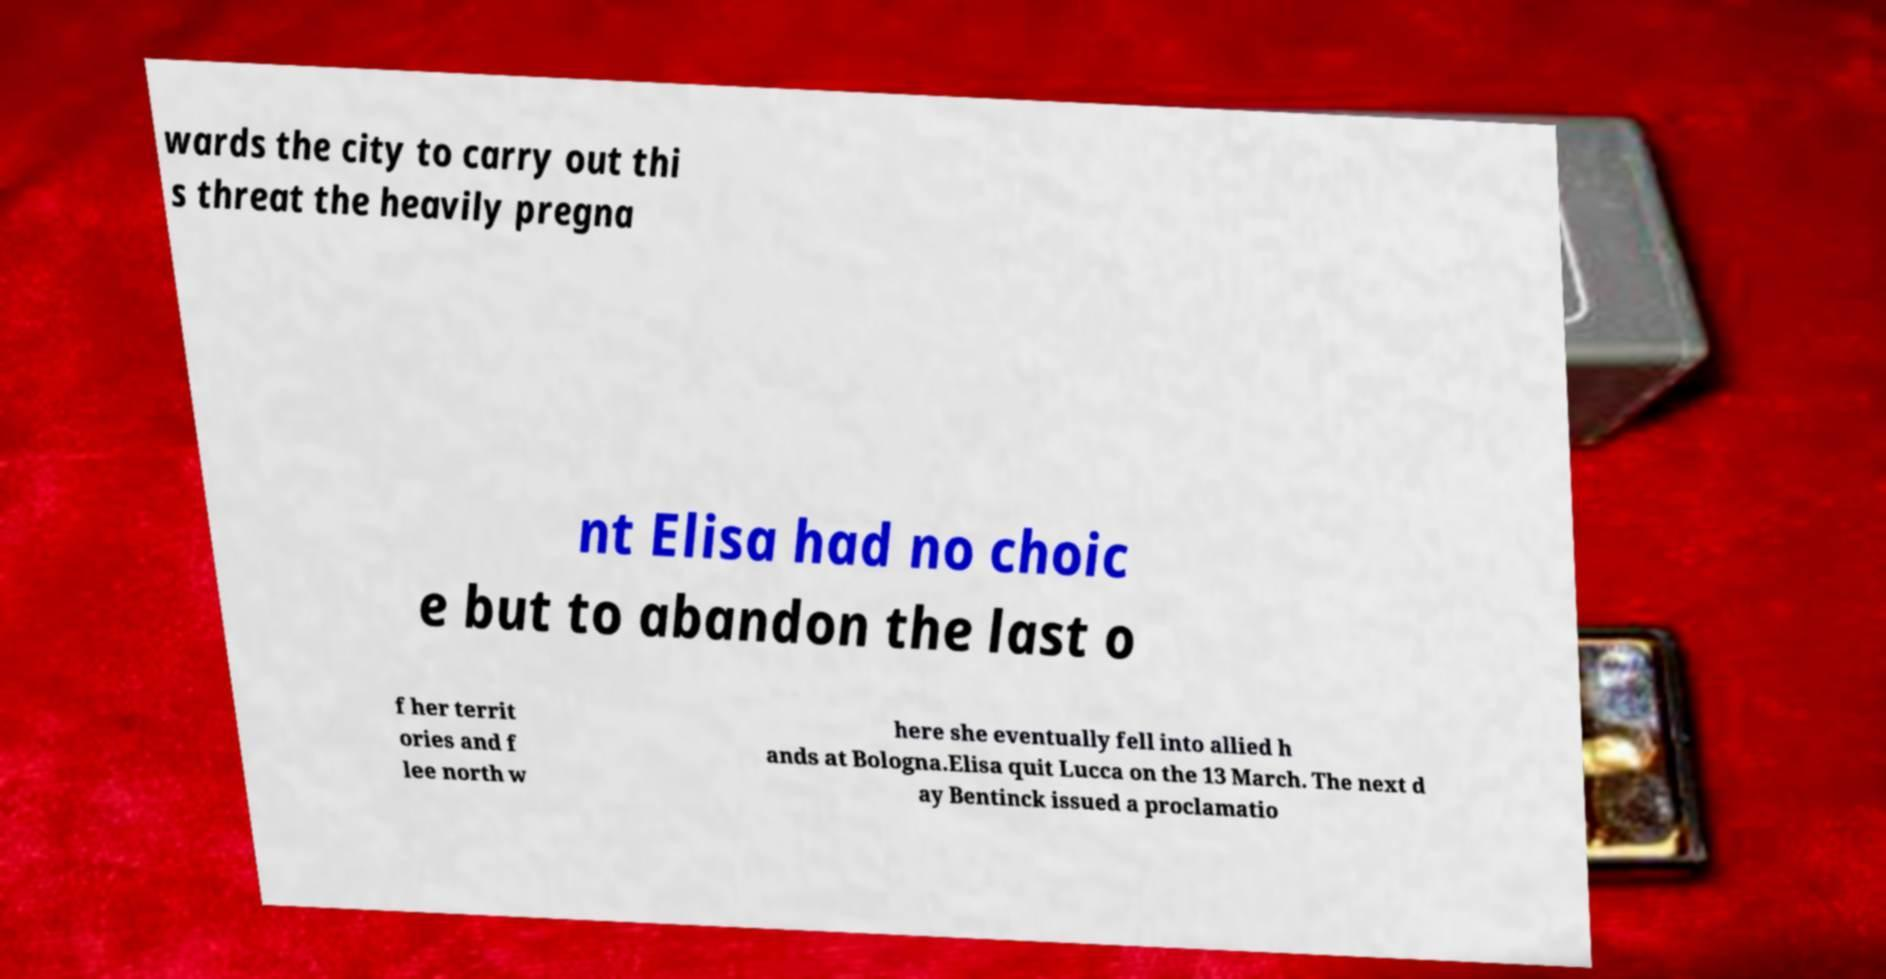Please identify and transcribe the text found in this image. wards the city to carry out thi s threat the heavily pregna nt Elisa had no choic e but to abandon the last o f her territ ories and f lee north w here she eventually fell into allied h ands at Bologna.Elisa quit Lucca on the 13 March. The next d ay Bentinck issued a proclamatio 